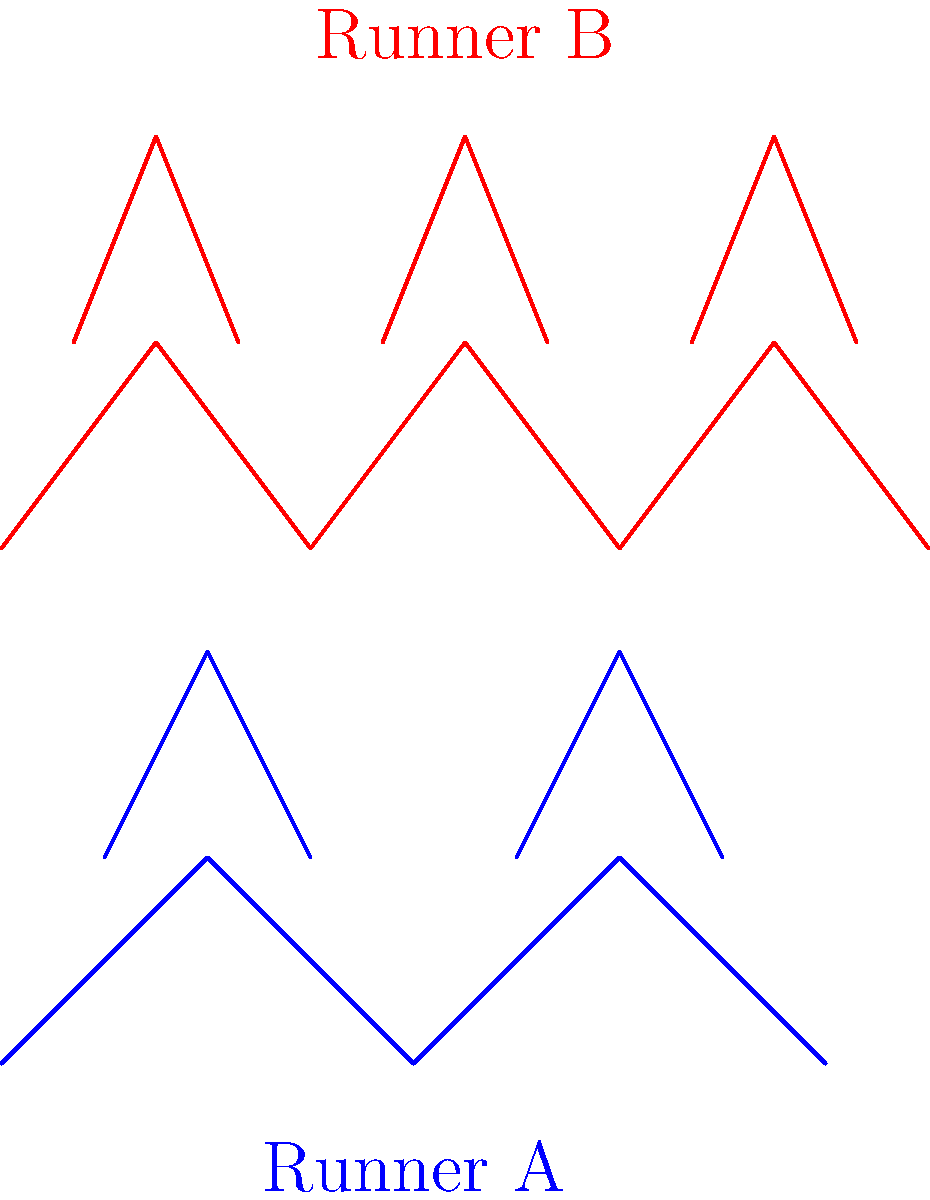Based on the stick figure animations of two runners, what key biomechanical difference can you identify between their running styles, and how might this impact their performance on the court? To analyze the biomechanical differences between these two runners, let's break it down step-by-step:

1. Stride Length:
   - Runner A (blue) has a longer stride length, covering more distance with each step.
   - Runner B (red) has a shorter stride length, taking more frequent steps.

2. Cadence (step frequency):
   - Runner A has a lower cadence, with fewer steps shown in the same horizontal distance.
   - Runner B has a higher cadence, with more steps shown in the same horizontal distance.

3. Vertical Oscillation:
   - Runner A appears to have less vertical movement in their running cycle.
   - Runner B shows more pronounced up-and-down motion, indicated by higher knee lift.

4. Impact on Performance:
   - Longer strides (Runner A) can be more efficient for covering long distances quickly, which may be beneficial for fast breaks or covering the full court.
   - Higher cadence (Runner B) can provide better agility and quicker changes of direction, which is advantageous for defensive movements and quick offensive maneuvers.
   - The higher vertical oscillation of Runner B may provide more explosive power for jumps but could potentially lead to faster fatigue over long periods.

5. Application to Basketball:
   - Players with longer strides might excel in transition plays and covering the court quickly.
   - Players with higher cadence might have an advantage in defensive sliding, quick cuts, and changes of direction.

6. Energy Efficiency:
   - Runner A's style may be more energy-efficient for sustained running.
   - Runner B's style may require more energy but could provide better responsiveness in short bursts.

The optimal running style for a basketball player would depend on their position and role on the team. A balance between these two styles might be ideal for all-around performance on the court.
Answer: Runner A has longer strides with lower cadence, while Runner B has shorter strides with higher cadence and more vertical oscillation. 